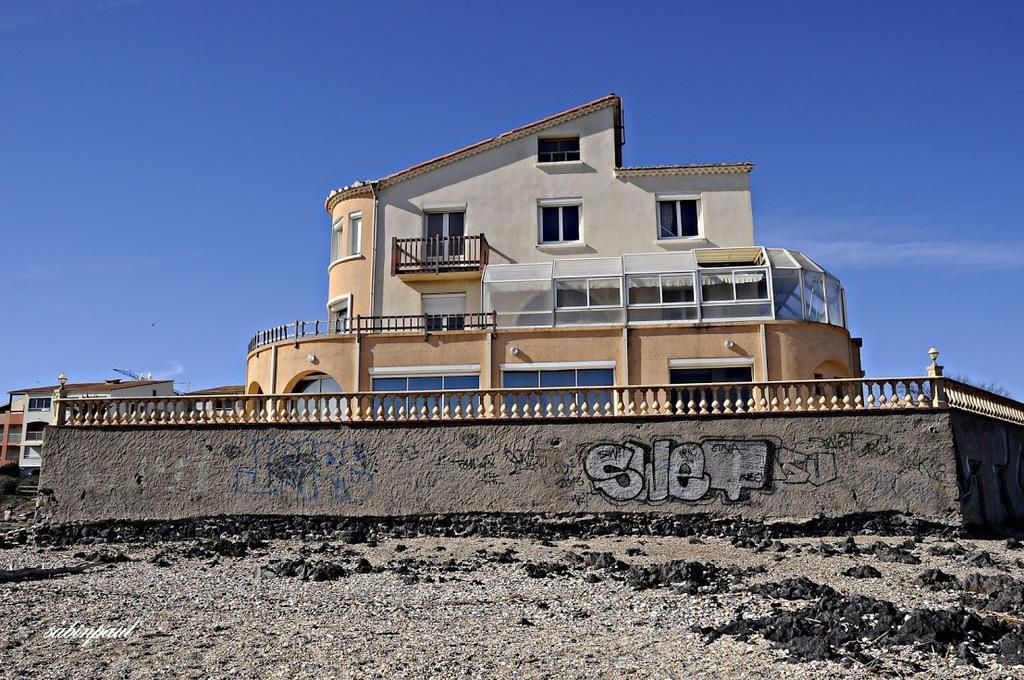Please provide a concise description of this image. In this picture I can see there is a building and it has a balcony, doors, windows and there is a wall in front of the building and in the backdrop there are few more buildings and the sky is clear. 